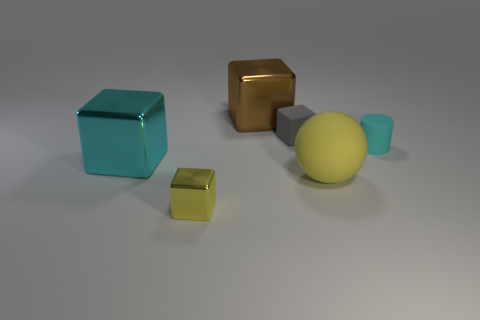Add 4 cubes. How many objects exist? 10 Subtract all cubes. How many objects are left? 2 Add 1 shiny objects. How many shiny objects exist? 4 Subtract 0 green blocks. How many objects are left? 6 Subtract all large cyan blocks. Subtract all small cylinders. How many objects are left? 4 Add 1 tiny gray blocks. How many tiny gray blocks are left? 2 